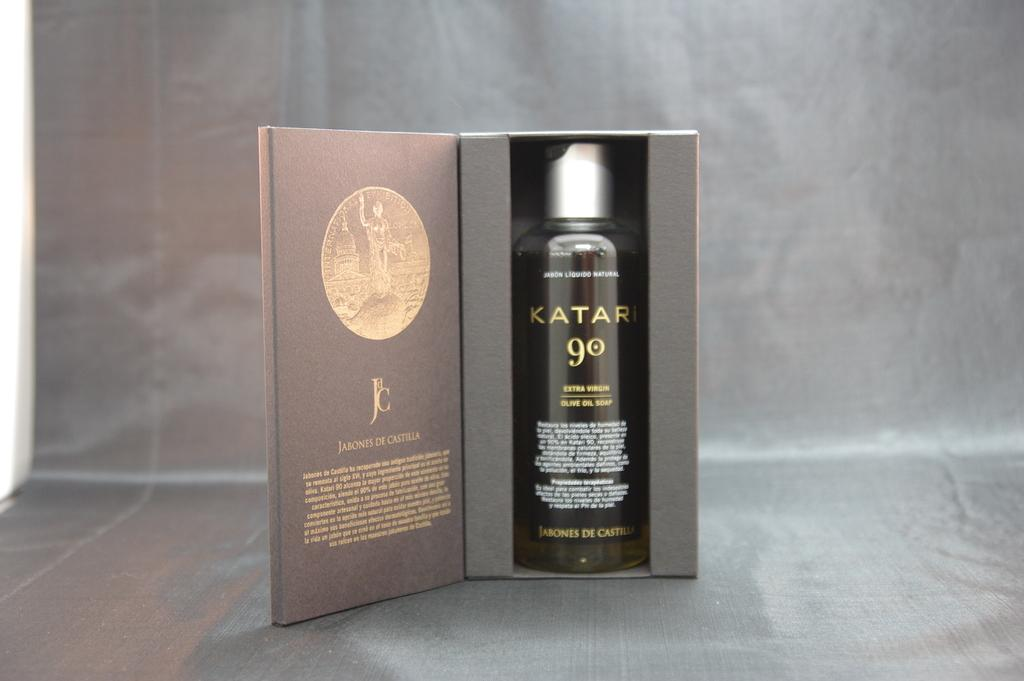<image>
Summarize the visual content of the image. a bottle of katari 90 in a grey and gold box 